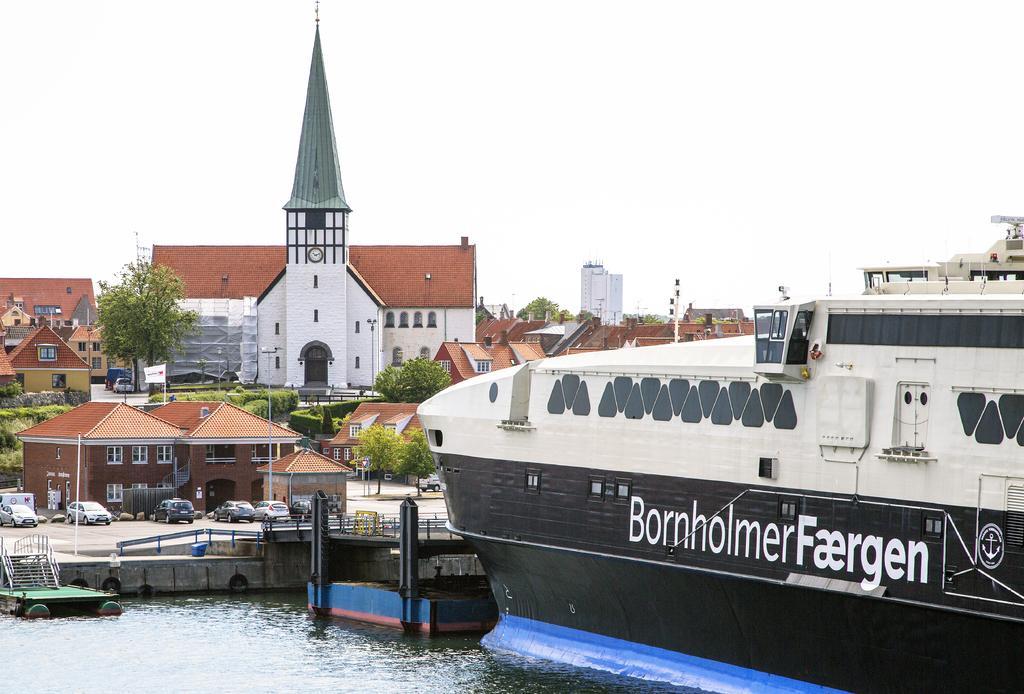Please provide a concise description of this image. This picture is clicked outside. On the right there is a ship in the water body. In the center we can see the buildings, trees and some vehicles and a spire. In the background there is a sky and some other items and we can see the text on the ship. On the left corner there is a staircase. 